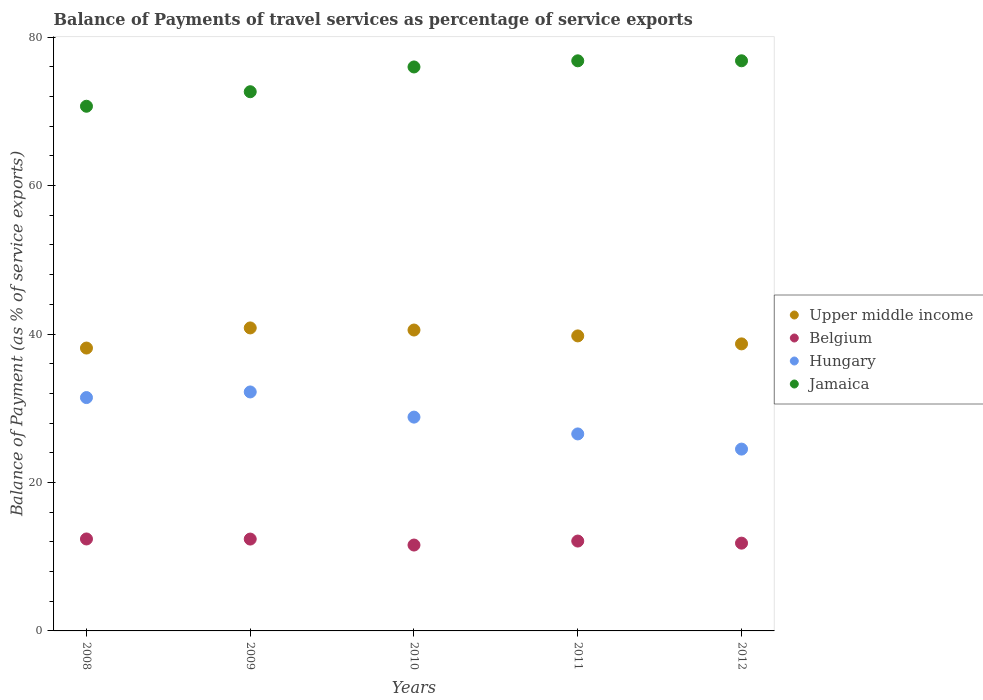Is the number of dotlines equal to the number of legend labels?
Your answer should be very brief. Yes. What is the balance of payments of travel services in Upper middle income in 2008?
Give a very brief answer. 38.11. Across all years, what is the maximum balance of payments of travel services in Jamaica?
Keep it short and to the point. 76.81. Across all years, what is the minimum balance of payments of travel services in Jamaica?
Ensure brevity in your answer.  70.69. In which year was the balance of payments of travel services in Upper middle income maximum?
Keep it short and to the point. 2009. In which year was the balance of payments of travel services in Belgium minimum?
Your answer should be very brief. 2010. What is the total balance of payments of travel services in Hungary in the graph?
Ensure brevity in your answer.  143.47. What is the difference between the balance of payments of travel services in Hungary in 2010 and that in 2012?
Provide a succinct answer. 4.31. What is the difference between the balance of payments of travel services in Jamaica in 2009 and the balance of payments of travel services in Upper middle income in 2010?
Provide a succinct answer. 32.11. What is the average balance of payments of travel services in Belgium per year?
Give a very brief answer. 12.05. In the year 2012, what is the difference between the balance of payments of travel services in Belgium and balance of payments of travel services in Jamaica?
Your answer should be compact. -64.99. In how many years, is the balance of payments of travel services in Jamaica greater than 12 %?
Give a very brief answer. 5. What is the ratio of the balance of payments of travel services in Upper middle income in 2011 to that in 2012?
Make the answer very short. 1.03. Is the balance of payments of travel services in Hungary in 2008 less than that in 2010?
Your answer should be very brief. No. Is the difference between the balance of payments of travel services in Belgium in 2009 and 2012 greater than the difference between the balance of payments of travel services in Jamaica in 2009 and 2012?
Provide a short and direct response. Yes. What is the difference between the highest and the second highest balance of payments of travel services in Belgium?
Offer a very short reply. 0.01. What is the difference between the highest and the lowest balance of payments of travel services in Belgium?
Your response must be concise. 0.82. Is the sum of the balance of payments of travel services in Belgium in 2010 and 2012 greater than the maximum balance of payments of travel services in Hungary across all years?
Your answer should be compact. No. Is it the case that in every year, the sum of the balance of payments of travel services in Jamaica and balance of payments of travel services in Upper middle income  is greater than the sum of balance of payments of travel services in Belgium and balance of payments of travel services in Hungary?
Keep it short and to the point. No. Is the balance of payments of travel services in Hungary strictly greater than the balance of payments of travel services in Jamaica over the years?
Your answer should be compact. No. Is the balance of payments of travel services in Jamaica strictly less than the balance of payments of travel services in Belgium over the years?
Your answer should be very brief. No. How many years are there in the graph?
Provide a succinct answer. 5. Are the values on the major ticks of Y-axis written in scientific E-notation?
Provide a succinct answer. No. Does the graph contain grids?
Make the answer very short. No. Where does the legend appear in the graph?
Give a very brief answer. Center right. How are the legend labels stacked?
Your answer should be compact. Vertical. What is the title of the graph?
Provide a succinct answer. Balance of Payments of travel services as percentage of service exports. What is the label or title of the Y-axis?
Keep it short and to the point. Balance of Payment (as % of service exports). What is the Balance of Payment (as % of service exports) of Upper middle income in 2008?
Provide a short and direct response. 38.11. What is the Balance of Payment (as % of service exports) of Belgium in 2008?
Provide a short and direct response. 12.39. What is the Balance of Payment (as % of service exports) of Hungary in 2008?
Provide a short and direct response. 31.44. What is the Balance of Payment (as % of service exports) in Jamaica in 2008?
Provide a succinct answer. 70.69. What is the Balance of Payment (as % of service exports) in Upper middle income in 2009?
Your response must be concise. 40.82. What is the Balance of Payment (as % of service exports) in Belgium in 2009?
Make the answer very short. 12.37. What is the Balance of Payment (as % of service exports) of Hungary in 2009?
Keep it short and to the point. 32.2. What is the Balance of Payment (as % of service exports) in Jamaica in 2009?
Give a very brief answer. 72.64. What is the Balance of Payment (as % of service exports) of Upper middle income in 2010?
Provide a short and direct response. 40.54. What is the Balance of Payment (as % of service exports) of Belgium in 2010?
Your answer should be very brief. 11.57. What is the Balance of Payment (as % of service exports) in Hungary in 2010?
Your response must be concise. 28.8. What is the Balance of Payment (as % of service exports) of Jamaica in 2010?
Provide a succinct answer. 75.98. What is the Balance of Payment (as % of service exports) of Upper middle income in 2011?
Provide a succinct answer. 39.75. What is the Balance of Payment (as % of service exports) in Belgium in 2011?
Your answer should be compact. 12.11. What is the Balance of Payment (as % of service exports) in Hungary in 2011?
Give a very brief answer. 26.54. What is the Balance of Payment (as % of service exports) of Jamaica in 2011?
Make the answer very short. 76.81. What is the Balance of Payment (as % of service exports) in Upper middle income in 2012?
Provide a succinct answer. 38.67. What is the Balance of Payment (as % of service exports) in Belgium in 2012?
Make the answer very short. 11.83. What is the Balance of Payment (as % of service exports) in Hungary in 2012?
Your response must be concise. 24.5. What is the Balance of Payment (as % of service exports) in Jamaica in 2012?
Make the answer very short. 76.81. Across all years, what is the maximum Balance of Payment (as % of service exports) in Upper middle income?
Provide a succinct answer. 40.82. Across all years, what is the maximum Balance of Payment (as % of service exports) in Belgium?
Make the answer very short. 12.39. Across all years, what is the maximum Balance of Payment (as % of service exports) in Hungary?
Offer a very short reply. 32.2. Across all years, what is the maximum Balance of Payment (as % of service exports) of Jamaica?
Your answer should be very brief. 76.81. Across all years, what is the minimum Balance of Payment (as % of service exports) of Upper middle income?
Give a very brief answer. 38.11. Across all years, what is the minimum Balance of Payment (as % of service exports) of Belgium?
Your response must be concise. 11.57. Across all years, what is the minimum Balance of Payment (as % of service exports) in Hungary?
Your response must be concise. 24.5. Across all years, what is the minimum Balance of Payment (as % of service exports) in Jamaica?
Provide a short and direct response. 70.69. What is the total Balance of Payment (as % of service exports) of Upper middle income in the graph?
Keep it short and to the point. 197.88. What is the total Balance of Payment (as % of service exports) of Belgium in the graph?
Your answer should be very brief. 60.27. What is the total Balance of Payment (as % of service exports) of Hungary in the graph?
Ensure brevity in your answer.  143.47. What is the total Balance of Payment (as % of service exports) in Jamaica in the graph?
Make the answer very short. 372.93. What is the difference between the Balance of Payment (as % of service exports) in Upper middle income in 2008 and that in 2009?
Give a very brief answer. -2.71. What is the difference between the Balance of Payment (as % of service exports) in Belgium in 2008 and that in 2009?
Your answer should be very brief. 0.01. What is the difference between the Balance of Payment (as % of service exports) of Hungary in 2008 and that in 2009?
Your response must be concise. -0.76. What is the difference between the Balance of Payment (as % of service exports) in Jamaica in 2008 and that in 2009?
Make the answer very short. -1.96. What is the difference between the Balance of Payment (as % of service exports) in Upper middle income in 2008 and that in 2010?
Keep it short and to the point. -2.43. What is the difference between the Balance of Payment (as % of service exports) of Belgium in 2008 and that in 2010?
Offer a very short reply. 0.82. What is the difference between the Balance of Payment (as % of service exports) in Hungary in 2008 and that in 2010?
Make the answer very short. 2.63. What is the difference between the Balance of Payment (as % of service exports) in Jamaica in 2008 and that in 2010?
Ensure brevity in your answer.  -5.29. What is the difference between the Balance of Payment (as % of service exports) in Upper middle income in 2008 and that in 2011?
Your response must be concise. -1.64. What is the difference between the Balance of Payment (as % of service exports) in Belgium in 2008 and that in 2011?
Ensure brevity in your answer.  0.28. What is the difference between the Balance of Payment (as % of service exports) in Hungary in 2008 and that in 2011?
Keep it short and to the point. 4.9. What is the difference between the Balance of Payment (as % of service exports) in Jamaica in 2008 and that in 2011?
Your answer should be compact. -6.12. What is the difference between the Balance of Payment (as % of service exports) of Upper middle income in 2008 and that in 2012?
Your response must be concise. -0.56. What is the difference between the Balance of Payment (as % of service exports) of Belgium in 2008 and that in 2012?
Offer a terse response. 0.56. What is the difference between the Balance of Payment (as % of service exports) of Hungary in 2008 and that in 2012?
Keep it short and to the point. 6.94. What is the difference between the Balance of Payment (as % of service exports) in Jamaica in 2008 and that in 2012?
Your answer should be very brief. -6.12. What is the difference between the Balance of Payment (as % of service exports) of Upper middle income in 2009 and that in 2010?
Your response must be concise. 0.28. What is the difference between the Balance of Payment (as % of service exports) in Belgium in 2009 and that in 2010?
Make the answer very short. 0.81. What is the difference between the Balance of Payment (as % of service exports) in Hungary in 2009 and that in 2010?
Give a very brief answer. 3.39. What is the difference between the Balance of Payment (as % of service exports) in Jamaica in 2009 and that in 2010?
Provide a succinct answer. -3.34. What is the difference between the Balance of Payment (as % of service exports) in Upper middle income in 2009 and that in 2011?
Make the answer very short. 1.07. What is the difference between the Balance of Payment (as % of service exports) of Belgium in 2009 and that in 2011?
Your answer should be compact. 0.27. What is the difference between the Balance of Payment (as % of service exports) of Hungary in 2009 and that in 2011?
Make the answer very short. 5.65. What is the difference between the Balance of Payment (as % of service exports) in Jamaica in 2009 and that in 2011?
Offer a very short reply. -4.16. What is the difference between the Balance of Payment (as % of service exports) of Upper middle income in 2009 and that in 2012?
Your answer should be compact. 2.15. What is the difference between the Balance of Payment (as % of service exports) of Belgium in 2009 and that in 2012?
Provide a succinct answer. 0.55. What is the difference between the Balance of Payment (as % of service exports) in Jamaica in 2009 and that in 2012?
Offer a very short reply. -4.17. What is the difference between the Balance of Payment (as % of service exports) in Upper middle income in 2010 and that in 2011?
Your answer should be compact. 0.79. What is the difference between the Balance of Payment (as % of service exports) of Belgium in 2010 and that in 2011?
Your answer should be very brief. -0.54. What is the difference between the Balance of Payment (as % of service exports) of Hungary in 2010 and that in 2011?
Offer a very short reply. 2.26. What is the difference between the Balance of Payment (as % of service exports) in Jamaica in 2010 and that in 2011?
Ensure brevity in your answer.  -0.83. What is the difference between the Balance of Payment (as % of service exports) in Upper middle income in 2010 and that in 2012?
Ensure brevity in your answer.  1.87. What is the difference between the Balance of Payment (as % of service exports) of Belgium in 2010 and that in 2012?
Make the answer very short. -0.26. What is the difference between the Balance of Payment (as % of service exports) of Hungary in 2010 and that in 2012?
Your answer should be very brief. 4.31. What is the difference between the Balance of Payment (as % of service exports) in Jamaica in 2010 and that in 2012?
Provide a succinct answer. -0.83. What is the difference between the Balance of Payment (as % of service exports) of Upper middle income in 2011 and that in 2012?
Make the answer very short. 1.07. What is the difference between the Balance of Payment (as % of service exports) of Belgium in 2011 and that in 2012?
Keep it short and to the point. 0.28. What is the difference between the Balance of Payment (as % of service exports) in Hungary in 2011 and that in 2012?
Provide a short and direct response. 2.05. What is the difference between the Balance of Payment (as % of service exports) in Jamaica in 2011 and that in 2012?
Keep it short and to the point. -0. What is the difference between the Balance of Payment (as % of service exports) in Upper middle income in 2008 and the Balance of Payment (as % of service exports) in Belgium in 2009?
Your response must be concise. 25.73. What is the difference between the Balance of Payment (as % of service exports) in Upper middle income in 2008 and the Balance of Payment (as % of service exports) in Hungary in 2009?
Provide a succinct answer. 5.91. What is the difference between the Balance of Payment (as % of service exports) of Upper middle income in 2008 and the Balance of Payment (as % of service exports) of Jamaica in 2009?
Your answer should be compact. -34.53. What is the difference between the Balance of Payment (as % of service exports) in Belgium in 2008 and the Balance of Payment (as % of service exports) in Hungary in 2009?
Your response must be concise. -19.81. What is the difference between the Balance of Payment (as % of service exports) of Belgium in 2008 and the Balance of Payment (as % of service exports) of Jamaica in 2009?
Offer a very short reply. -60.25. What is the difference between the Balance of Payment (as % of service exports) of Hungary in 2008 and the Balance of Payment (as % of service exports) of Jamaica in 2009?
Your answer should be compact. -41.21. What is the difference between the Balance of Payment (as % of service exports) of Upper middle income in 2008 and the Balance of Payment (as % of service exports) of Belgium in 2010?
Provide a succinct answer. 26.54. What is the difference between the Balance of Payment (as % of service exports) of Upper middle income in 2008 and the Balance of Payment (as % of service exports) of Hungary in 2010?
Ensure brevity in your answer.  9.3. What is the difference between the Balance of Payment (as % of service exports) of Upper middle income in 2008 and the Balance of Payment (as % of service exports) of Jamaica in 2010?
Ensure brevity in your answer.  -37.87. What is the difference between the Balance of Payment (as % of service exports) in Belgium in 2008 and the Balance of Payment (as % of service exports) in Hungary in 2010?
Provide a short and direct response. -16.42. What is the difference between the Balance of Payment (as % of service exports) in Belgium in 2008 and the Balance of Payment (as % of service exports) in Jamaica in 2010?
Give a very brief answer. -63.59. What is the difference between the Balance of Payment (as % of service exports) in Hungary in 2008 and the Balance of Payment (as % of service exports) in Jamaica in 2010?
Offer a very short reply. -44.54. What is the difference between the Balance of Payment (as % of service exports) of Upper middle income in 2008 and the Balance of Payment (as % of service exports) of Belgium in 2011?
Provide a succinct answer. 26. What is the difference between the Balance of Payment (as % of service exports) in Upper middle income in 2008 and the Balance of Payment (as % of service exports) in Hungary in 2011?
Offer a terse response. 11.57. What is the difference between the Balance of Payment (as % of service exports) of Upper middle income in 2008 and the Balance of Payment (as % of service exports) of Jamaica in 2011?
Ensure brevity in your answer.  -38.7. What is the difference between the Balance of Payment (as % of service exports) in Belgium in 2008 and the Balance of Payment (as % of service exports) in Hungary in 2011?
Keep it short and to the point. -14.15. What is the difference between the Balance of Payment (as % of service exports) in Belgium in 2008 and the Balance of Payment (as % of service exports) in Jamaica in 2011?
Your answer should be very brief. -64.42. What is the difference between the Balance of Payment (as % of service exports) of Hungary in 2008 and the Balance of Payment (as % of service exports) of Jamaica in 2011?
Your answer should be compact. -45.37. What is the difference between the Balance of Payment (as % of service exports) of Upper middle income in 2008 and the Balance of Payment (as % of service exports) of Belgium in 2012?
Make the answer very short. 26.28. What is the difference between the Balance of Payment (as % of service exports) of Upper middle income in 2008 and the Balance of Payment (as % of service exports) of Hungary in 2012?
Your response must be concise. 13.61. What is the difference between the Balance of Payment (as % of service exports) of Upper middle income in 2008 and the Balance of Payment (as % of service exports) of Jamaica in 2012?
Give a very brief answer. -38.7. What is the difference between the Balance of Payment (as % of service exports) in Belgium in 2008 and the Balance of Payment (as % of service exports) in Hungary in 2012?
Your answer should be compact. -12.11. What is the difference between the Balance of Payment (as % of service exports) of Belgium in 2008 and the Balance of Payment (as % of service exports) of Jamaica in 2012?
Keep it short and to the point. -64.42. What is the difference between the Balance of Payment (as % of service exports) in Hungary in 2008 and the Balance of Payment (as % of service exports) in Jamaica in 2012?
Your response must be concise. -45.37. What is the difference between the Balance of Payment (as % of service exports) in Upper middle income in 2009 and the Balance of Payment (as % of service exports) in Belgium in 2010?
Make the answer very short. 29.25. What is the difference between the Balance of Payment (as % of service exports) in Upper middle income in 2009 and the Balance of Payment (as % of service exports) in Hungary in 2010?
Your answer should be very brief. 12.02. What is the difference between the Balance of Payment (as % of service exports) of Upper middle income in 2009 and the Balance of Payment (as % of service exports) of Jamaica in 2010?
Give a very brief answer. -35.16. What is the difference between the Balance of Payment (as % of service exports) in Belgium in 2009 and the Balance of Payment (as % of service exports) in Hungary in 2010?
Provide a succinct answer. -16.43. What is the difference between the Balance of Payment (as % of service exports) of Belgium in 2009 and the Balance of Payment (as % of service exports) of Jamaica in 2010?
Keep it short and to the point. -63.6. What is the difference between the Balance of Payment (as % of service exports) in Hungary in 2009 and the Balance of Payment (as % of service exports) in Jamaica in 2010?
Keep it short and to the point. -43.78. What is the difference between the Balance of Payment (as % of service exports) in Upper middle income in 2009 and the Balance of Payment (as % of service exports) in Belgium in 2011?
Make the answer very short. 28.71. What is the difference between the Balance of Payment (as % of service exports) of Upper middle income in 2009 and the Balance of Payment (as % of service exports) of Hungary in 2011?
Offer a terse response. 14.28. What is the difference between the Balance of Payment (as % of service exports) of Upper middle income in 2009 and the Balance of Payment (as % of service exports) of Jamaica in 2011?
Keep it short and to the point. -35.99. What is the difference between the Balance of Payment (as % of service exports) in Belgium in 2009 and the Balance of Payment (as % of service exports) in Hungary in 2011?
Give a very brief answer. -14.17. What is the difference between the Balance of Payment (as % of service exports) of Belgium in 2009 and the Balance of Payment (as % of service exports) of Jamaica in 2011?
Your response must be concise. -64.43. What is the difference between the Balance of Payment (as % of service exports) in Hungary in 2009 and the Balance of Payment (as % of service exports) in Jamaica in 2011?
Your answer should be compact. -44.61. What is the difference between the Balance of Payment (as % of service exports) of Upper middle income in 2009 and the Balance of Payment (as % of service exports) of Belgium in 2012?
Provide a succinct answer. 29. What is the difference between the Balance of Payment (as % of service exports) in Upper middle income in 2009 and the Balance of Payment (as % of service exports) in Hungary in 2012?
Provide a succinct answer. 16.32. What is the difference between the Balance of Payment (as % of service exports) in Upper middle income in 2009 and the Balance of Payment (as % of service exports) in Jamaica in 2012?
Offer a terse response. -35.99. What is the difference between the Balance of Payment (as % of service exports) of Belgium in 2009 and the Balance of Payment (as % of service exports) of Hungary in 2012?
Your answer should be compact. -12.12. What is the difference between the Balance of Payment (as % of service exports) in Belgium in 2009 and the Balance of Payment (as % of service exports) in Jamaica in 2012?
Provide a succinct answer. -64.44. What is the difference between the Balance of Payment (as % of service exports) in Hungary in 2009 and the Balance of Payment (as % of service exports) in Jamaica in 2012?
Give a very brief answer. -44.62. What is the difference between the Balance of Payment (as % of service exports) of Upper middle income in 2010 and the Balance of Payment (as % of service exports) of Belgium in 2011?
Your answer should be very brief. 28.43. What is the difference between the Balance of Payment (as % of service exports) of Upper middle income in 2010 and the Balance of Payment (as % of service exports) of Hungary in 2011?
Make the answer very short. 14. What is the difference between the Balance of Payment (as % of service exports) in Upper middle income in 2010 and the Balance of Payment (as % of service exports) in Jamaica in 2011?
Offer a very short reply. -36.27. What is the difference between the Balance of Payment (as % of service exports) of Belgium in 2010 and the Balance of Payment (as % of service exports) of Hungary in 2011?
Your answer should be compact. -14.97. What is the difference between the Balance of Payment (as % of service exports) in Belgium in 2010 and the Balance of Payment (as % of service exports) in Jamaica in 2011?
Your answer should be compact. -65.24. What is the difference between the Balance of Payment (as % of service exports) in Hungary in 2010 and the Balance of Payment (as % of service exports) in Jamaica in 2011?
Your answer should be very brief. -48. What is the difference between the Balance of Payment (as % of service exports) of Upper middle income in 2010 and the Balance of Payment (as % of service exports) of Belgium in 2012?
Provide a short and direct response. 28.71. What is the difference between the Balance of Payment (as % of service exports) of Upper middle income in 2010 and the Balance of Payment (as % of service exports) of Hungary in 2012?
Offer a terse response. 16.04. What is the difference between the Balance of Payment (as % of service exports) of Upper middle income in 2010 and the Balance of Payment (as % of service exports) of Jamaica in 2012?
Your answer should be very brief. -36.27. What is the difference between the Balance of Payment (as % of service exports) of Belgium in 2010 and the Balance of Payment (as % of service exports) of Hungary in 2012?
Your response must be concise. -12.93. What is the difference between the Balance of Payment (as % of service exports) of Belgium in 2010 and the Balance of Payment (as % of service exports) of Jamaica in 2012?
Offer a very short reply. -65.24. What is the difference between the Balance of Payment (as % of service exports) of Hungary in 2010 and the Balance of Payment (as % of service exports) of Jamaica in 2012?
Offer a terse response. -48.01. What is the difference between the Balance of Payment (as % of service exports) of Upper middle income in 2011 and the Balance of Payment (as % of service exports) of Belgium in 2012?
Give a very brief answer. 27.92. What is the difference between the Balance of Payment (as % of service exports) of Upper middle income in 2011 and the Balance of Payment (as % of service exports) of Hungary in 2012?
Ensure brevity in your answer.  15.25. What is the difference between the Balance of Payment (as % of service exports) in Upper middle income in 2011 and the Balance of Payment (as % of service exports) in Jamaica in 2012?
Offer a very short reply. -37.06. What is the difference between the Balance of Payment (as % of service exports) of Belgium in 2011 and the Balance of Payment (as % of service exports) of Hungary in 2012?
Provide a short and direct response. -12.39. What is the difference between the Balance of Payment (as % of service exports) in Belgium in 2011 and the Balance of Payment (as % of service exports) in Jamaica in 2012?
Your answer should be compact. -64.7. What is the difference between the Balance of Payment (as % of service exports) in Hungary in 2011 and the Balance of Payment (as % of service exports) in Jamaica in 2012?
Your response must be concise. -50.27. What is the average Balance of Payment (as % of service exports) of Upper middle income per year?
Offer a terse response. 39.58. What is the average Balance of Payment (as % of service exports) in Belgium per year?
Provide a short and direct response. 12.05. What is the average Balance of Payment (as % of service exports) in Hungary per year?
Offer a very short reply. 28.69. What is the average Balance of Payment (as % of service exports) of Jamaica per year?
Offer a very short reply. 74.59. In the year 2008, what is the difference between the Balance of Payment (as % of service exports) in Upper middle income and Balance of Payment (as % of service exports) in Belgium?
Make the answer very short. 25.72. In the year 2008, what is the difference between the Balance of Payment (as % of service exports) of Upper middle income and Balance of Payment (as % of service exports) of Hungary?
Your response must be concise. 6.67. In the year 2008, what is the difference between the Balance of Payment (as % of service exports) of Upper middle income and Balance of Payment (as % of service exports) of Jamaica?
Offer a terse response. -32.58. In the year 2008, what is the difference between the Balance of Payment (as % of service exports) in Belgium and Balance of Payment (as % of service exports) in Hungary?
Ensure brevity in your answer.  -19.05. In the year 2008, what is the difference between the Balance of Payment (as % of service exports) in Belgium and Balance of Payment (as % of service exports) in Jamaica?
Keep it short and to the point. -58.3. In the year 2008, what is the difference between the Balance of Payment (as % of service exports) in Hungary and Balance of Payment (as % of service exports) in Jamaica?
Provide a succinct answer. -39.25. In the year 2009, what is the difference between the Balance of Payment (as % of service exports) in Upper middle income and Balance of Payment (as % of service exports) in Belgium?
Provide a short and direct response. 28.45. In the year 2009, what is the difference between the Balance of Payment (as % of service exports) of Upper middle income and Balance of Payment (as % of service exports) of Hungary?
Your answer should be compact. 8.62. In the year 2009, what is the difference between the Balance of Payment (as % of service exports) in Upper middle income and Balance of Payment (as % of service exports) in Jamaica?
Give a very brief answer. -31.82. In the year 2009, what is the difference between the Balance of Payment (as % of service exports) of Belgium and Balance of Payment (as % of service exports) of Hungary?
Offer a terse response. -19.82. In the year 2009, what is the difference between the Balance of Payment (as % of service exports) of Belgium and Balance of Payment (as % of service exports) of Jamaica?
Give a very brief answer. -60.27. In the year 2009, what is the difference between the Balance of Payment (as % of service exports) of Hungary and Balance of Payment (as % of service exports) of Jamaica?
Your answer should be very brief. -40.45. In the year 2010, what is the difference between the Balance of Payment (as % of service exports) of Upper middle income and Balance of Payment (as % of service exports) of Belgium?
Your response must be concise. 28.97. In the year 2010, what is the difference between the Balance of Payment (as % of service exports) of Upper middle income and Balance of Payment (as % of service exports) of Hungary?
Provide a succinct answer. 11.73. In the year 2010, what is the difference between the Balance of Payment (as % of service exports) in Upper middle income and Balance of Payment (as % of service exports) in Jamaica?
Give a very brief answer. -35.44. In the year 2010, what is the difference between the Balance of Payment (as % of service exports) in Belgium and Balance of Payment (as % of service exports) in Hungary?
Offer a very short reply. -17.23. In the year 2010, what is the difference between the Balance of Payment (as % of service exports) of Belgium and Balance of Payment (as % of service exports) of Jamaica?
Your answer should be very brief. -64.41. In the year 2010, what is the difference between the Balance of Payment (as % of service exports) of Hungary and Balance of Payment (as % of service exports) of Jamaica?
Give a very brief answer. -47.17. In the year 2011, what is the difference between the Balance of Payment (as % of service exports) of Upper middle income and Balance of Payment (as % of service exports) of Belgium?
Give a very brief answer. 27.64. In the year 2011, what is the difference between the Balance of Payment (as % of service exports) of Upper middle income and Balance of Payment (as % of service exports) of Hungary?
Provide a short and direct response. 13.21. In the year 2011, what is the difference between the Balance of Payment (as % of service exports) in Upper middle income and Balance of Payment (as % of service exports) in Jamaica?
Offer a terse response. -37.06. In the year 2011, what is the difference between the Balance of Payment (as % of service exports) in Belgium and Balance of Payment (as % of service exports) in Hungary?
Keep it short and to the point. -14.43. In the year 2011, what is the difference between the Balance of Payment (as % of service exports) of Belgium and Balance of Payment (as % of service exports) of Jamaica?
Offer a very short reply. -64.7. In the year 2011, what is the difference between the Balance of Payment (as % of service exports) in Hungary and Balance of Payment (as % of service exports) in Jamaica?
Give a very brief answer. -50.27. In the year 2012, what is the difference between the Balance of Payment (as % of service exports) of Upper middle income and Balance of Payment (as % of service exports) of Belgium?
Your answer should be compact. 26.85. In the year 2012, what is the difference between the Balance of Payment (as % of service exports) in Upper middle income and Balance of Payment (as % of service exports) in Hungary?
Keep it short and to the point. 14.18. In the year 2012, what is the difference between the Balance of Payment (as % of service exports) in Upper middle income and Balance of Payment (as % of service exports) in Jamaica?
Provide a succinct answer. -38.14. In the year 2012, what is the difference between the Balance of Payment (as % of service exports) in Belgium and Balance of Payment (as % of service exports) in Hungary?
Provide a short and direct response. -12.67. In the year 2012, what is the difference between the Balance of Payment (as % of service exports) in Belgium and Balance of Payment (as % of service exports) in Jamaica?
Provide a short and direct response. -64.99. In the year 2012, what is the difference between the Balance of Payment (as % of service exports) in Hungary and Balance of Payment (as % of service exports) in Jamaica?
Ensure brevity in your answer.  -52.32. What is the ratio of the Balance of Payment (as % of service exports) of Upper middle income in 2008 to that in 2009?
Your response must be concise. 0.93. What is the ratio of the Balance of Payment (as % of service exports) in Belgium in 2008 to that in 2009?
Provide a succinct answer. 1. What is the ratio of the Balance of Payment (as % of service exports) of Hungary in 2008 to that in 2009?
Ensure brevity in your answer.  0.98. What is the ratio of the Balance of Payment (as % of service exports) of Jamaica in 2008 to that in 2009?
Offer a very short reply. 0.97. What is the ratio of the Balance of Payment (as % of service exports) of Upper middle income in 2008 to that in 2010?
Make the answer very short. 0.94. What is the ratio of the Balance of Payment (as % of service exports) of Belgium in 2008 to that in 2010?
Your answer should be compact. 1.07. What is the ratio of the Balance of Payment (as % of service exports) of Hungary in 2008 to that in 2010?
Make the answer very short. 1.09. What is the ratio of the Balance of Payment (as % of service exports) in Jamaica in 2008 to that in 2010?
Give a very brief answer. 0.93. What is the ratio of the Balance of Payment (as % of service exports) of Upper middle income in 2008 to that in 2011?
Ensure brevity in your answer.  0.96. What is the ratio of the Balance of Payment (as % of service exports) in Belgium in 2008 to that in 2011?
Provide a short and direct response. 1.02. What is the ratio of the Balance of Payment (as % of service exports) in Hungary in 2008 to that in 2011?
Provide a succinct answer. 1.18. What is the ratio of the Balance of Payment (as % of service exports) in Jamaica in 2008 to that in 2011?
Provide a short and direct response. 0.92. What is the ratio of the Balance of Payment (as % of service exports) in Upper middle income in 2008 to that in 2012?
Ensure brevity in your answer.  0.99. What is the ratio of the Balance of Payment (as % of service exports) in Belgium in 2008 to that in 2012?
Your response must be concise. 1.05. What is the ratio of the Balance of Payment (as % of service exports) in Hungary in 2008 to that in 2012?
Your answer should be compact. 1.28. What is the ratio of the Balance of Payment (as % of service exports) of Jamaica in 2008 to that in 2012?
Offer a terse response. 0.92. What is the ratio of the Balance of Payment (as % of service exports) of Upper middle income in 2009 to that in 2010?
Ensure brevity in your answer.  1.01. What is the ratio of the Balance of Payment (as % of service exports) of Belgium in 2009 to that in 2010?
Make the answer very short. 1.07. What is the ratio of the Balance of Payment (as % of service exports) of Hungary in 2009 to that in 2010?
Offer a very short reply. 1.12. What is the ratio of the Balance of Payment (as % of service exports) of Jamaica in 2009 to that in 2010?
Your answer should be compact. 0.96. What is the ratio of the Balance of Payment (as % of service exports) of Belgium in 2009 to that in 2011?
Keep it short and to the point. 1.02. What is the ratio of the Balance of Payment (as % of service exports) of Hungary in 2009 to that in 2011?
Offer a very short reply. 1.21. What is the ratio of the Balance of Payment (as % of service exports) of Jamaica in 2009 to that in 2011?
Provide a short and direct response. 0.95. What is the ratio of the Balance of Payment (as % of service exports) in Upper middle income in 2009 to that in 2012?
Ensure brevity in your answer.  1.06. What is the ratio of the Balance of Payment (as % of service exports) in Belgium in 2009 to that in 2012?
Keep it short and to the point. 1.05. What is the ratio of the Balance of Payment (as % of service exports) in Hungary in 2009 to that in 2012?
Provide a short and direct response. 1.31. What is the ratio of the Balance of Payment (as % of service exports) of Jamaica in 2009 to that in 2012?
Your answer should be compact. 0.95. What is the ratio of the Balance of Payment (as % of service exports) of Upper middle income in 2010 to that in 2011?
Make the answer very short. 1.02. What is the ratio of the Balance of Payment (as % of service exports) in Belgium in 2010 to that in 2011?
Your response must be concise. 0.96. What is the ratio of the Balance of Payment (as % of service exports) in Hungary in 2010 to that in 2011?
Give a very brief answer. 1.09. What is the ratio of the Balance of Payment (as % of service exports) of Upper middle income in 2010 to that in 2012?
Give a very brief answer. 1.05. What is the ratio of the Balance of Payment (as % of service exports) of Belgium in 2010 to that in 2012?
Give a very brief answer. 0.98. What is the ratio of the Balance of Payment (as % of service exports) in Hungary in 2010 to that in 2012?
Give a very brief answer. 1.18. What is the ratio of the Balance of Payment (as % of service exports) in Upper middle income in 2011 to that in 2012?
Provide a short and direct response. 1.03. What is the ratio of the Balance of Payment (as % of service exports) in Belgium in 2011 to that in 2012?
Your answer should be very brief. 1.02. What is the ratio of the Balance of Payment (as % of service exports) of Hungary in 2011 to that in 2012?
Provide a short and direct response. 1.08. What is the difference between the highest and the second highest Balance of Payment (as % of service exports) of Upper middle income?
Your answer should be compact. 0.28. What is the difference between the highest and the second highest Balance of Payment (as % of service exports) of Belgium?
Provide a succinct answer. 0.01. What is the difference between the highest and the second highest Balance of Payment (as % of service exports) of Hungary?
Provide a succinct answer. 0.76. What is the difference between the highest and the second highest Balance of Payment (as % of service exports) in Jamaica?
Your response must be concise. 0. What is the difference between the highest and the lowest Balance of Payment (as % of service exports) of Upper middle income?
Offer a terse response. 2.71. What is the difference between the highest and the lowest Balance of Payment (as % of service exports) in Belgium?
Offer a terse response. 0.82. What is the difference between the highest and the lowest Balance of Payment (as % of service exports) of Hungary?
Keep it short and to the point. 7.7. What is the difference between the highest and the lowest Balance of Payment (as % of service exports) of Jamaica?
Your answer should be compact. 6.12. 